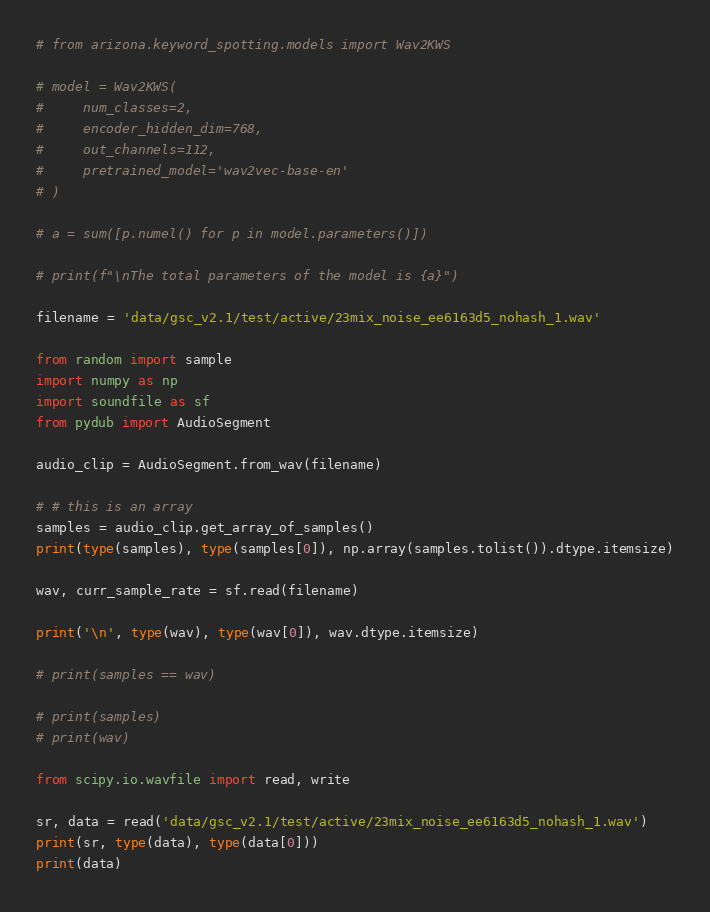<code> <loc_0><loc_0><loc_500><loc_500><_Python_># from arizona.keyword_spotting.models import Wav2KWS

# model = Wav2KWS(
#     num_classes=2,
#     encoder_hidden_dim=768,
#     out_channels=112,
#     pretrained_model='wav2vec-base-en'
# )

# a = sum([p.numel() for p in model.parameters()])

# print(f"\nThe total parameters of the model is {a}")

filename = 'data/gsc_v2.1/test/active/23mix_noise_ee6163d5_nohash_1.wav'

from random import sample
import numpy as np
import soundfile as sf
from pydub import AudioSegment

audio_clip = AudioSegment.from_wav(filename)

# # this is an array
samples = audio_clip.get_array_of_samples()
print(type(samples), type(samples[0]), np.array(samples.tolist()).dtype.itemsize)

wav, curr_sample_rate = sf.read(filename)

print('\n', type(wav), type(wav[0]), wav.dtype.itemsize)

# print(samples == wav)

# print(samples)
# print(wav)

from scipy.io.wavfile import read, write

sr, data = read('data/gsc_v2.1/test/active/23mix_noise_ee6163d5_nohash_1.wav')
print(sr, type(data), type(data[0]))
print(data)</code> 